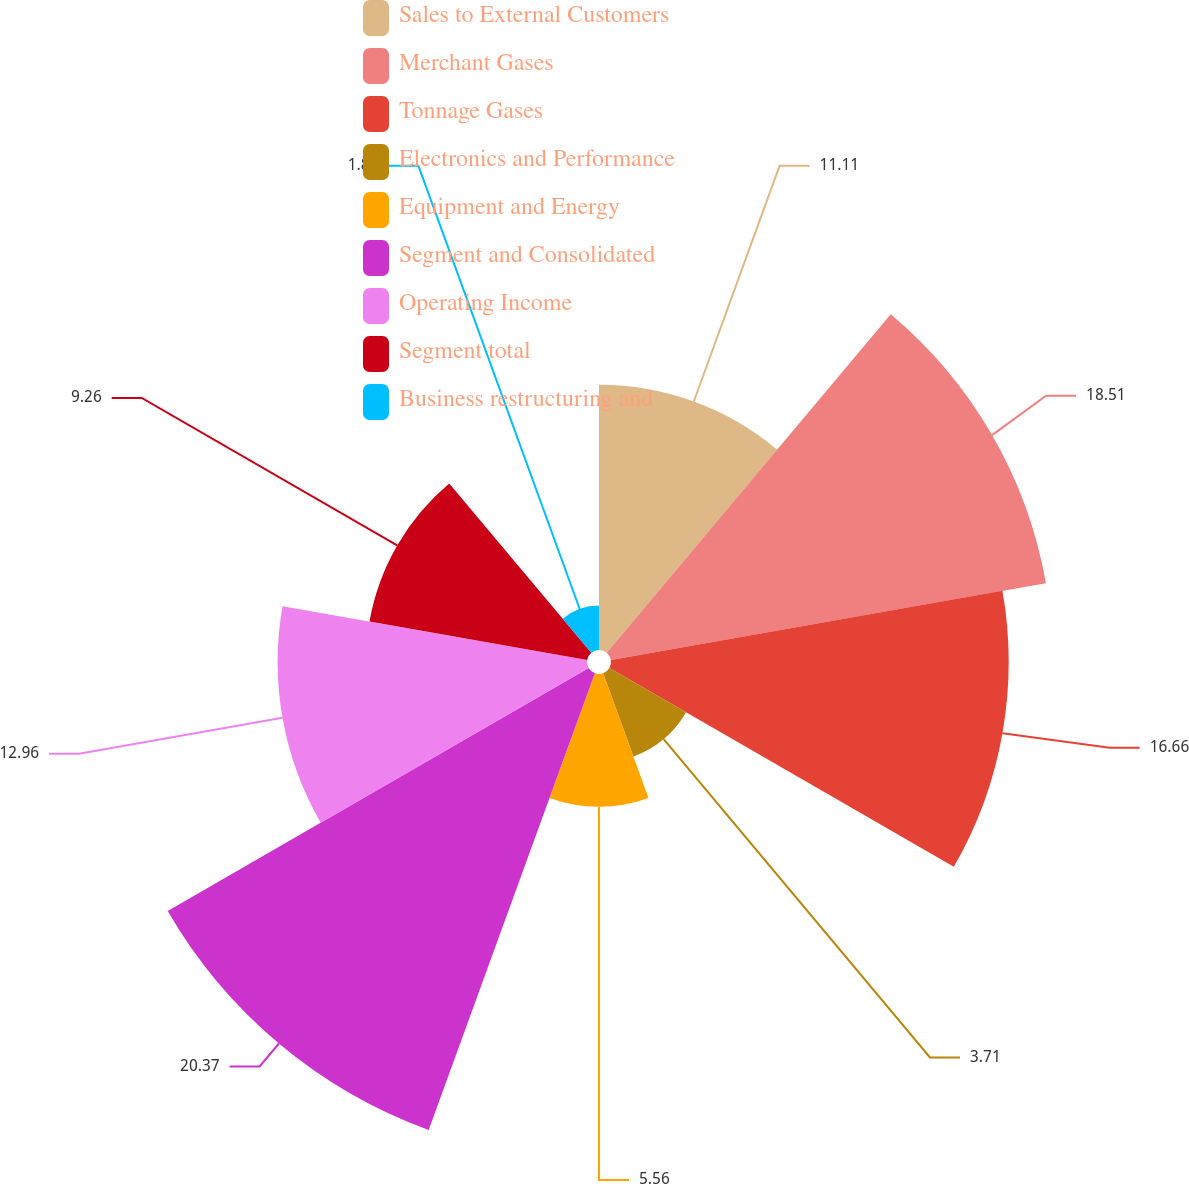Convert chart to OTSL. <chart><loc_0><loc_0><loc_500><loc_500><pie_chart><fcel>Sales to External Customers<fcel>Merchant Gases<fcel>Tonnage Gases<fcel>Electronics and Performance<fcel>Equipment and Energy<fcel>Segment and Consolidated<fcel>Operating Income<fcel>Segment total<fcel>Business restructuring and<nl><fcel>11.11%<fcel>18.51%<fcel>16.66%<fcel>3.71%<fcel>5.56%<fcel>20.36%<fcel>12.96%<fcel>9.26%<fcel>1.86%<nl></chart> 